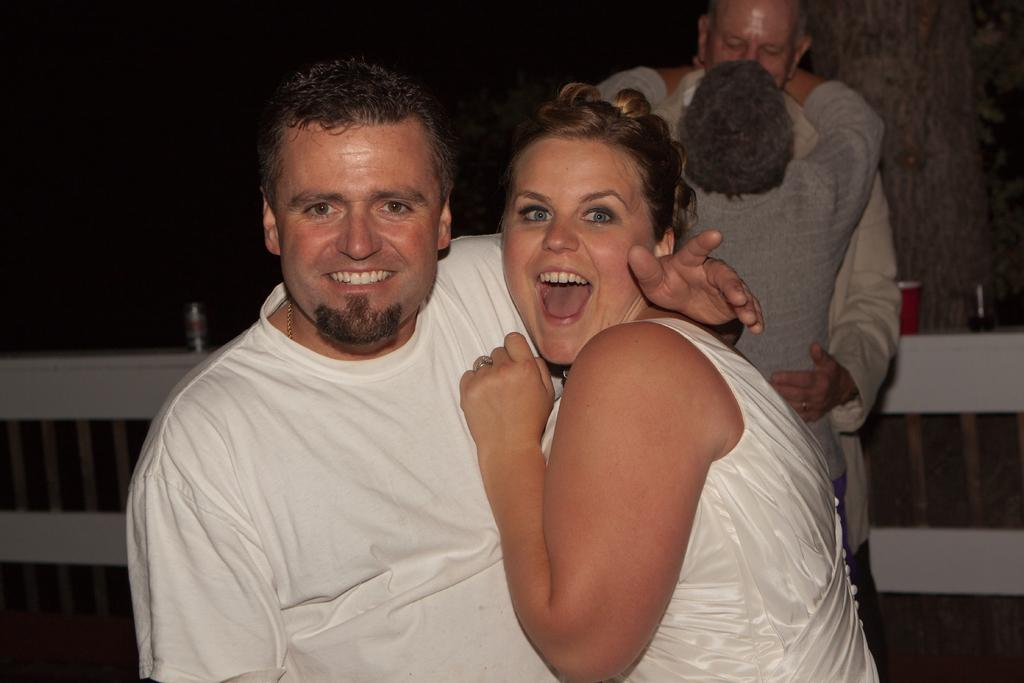How many people are in the image? There are four people in the image, including a man and a woman. What are the expressions on the faces of the man and woman? Both the man and woman are smiling in the image. Can you describe the background of the image? The background of the image is dark. What type of swing can be seen in the image? There is no swing present in the image. What is the cause of the man's smile in the image? The cause of the man's smile cannot be determined from the image alone. 